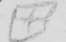What is written in this line of handwriting? [  +  ] 